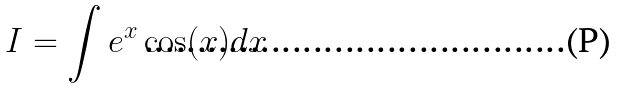Convert formula to latex. <formula><loc_0><loc_0><loc_500><loc_500>I = \int e ^ { x } \cos ( x ) d x</formula> 